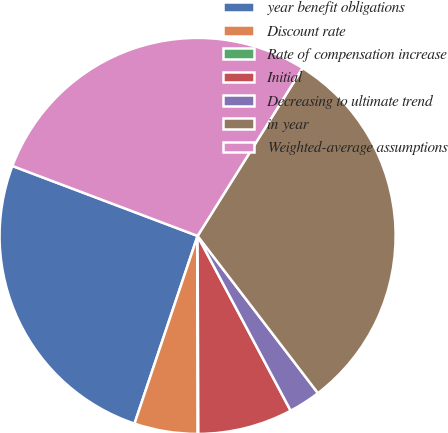Convert chart. <chart><loc_0><loc_0><loc_500><loc_500><pie_chart><fcel>year benefit obligations<fcel>Discount rate<fcel>Rate of compensation increase<fcel>Initial<fcel>Decreasing to ultimate trend<fcel>in year<fcel>Weighted-average assumptions<nl><fcel>25.59%<fcel>5.17%<fcel>0.05%<fcel>7.73%<fcel>2.61%<fcel>30.71%<fcel>28.15%<nl></chart> 